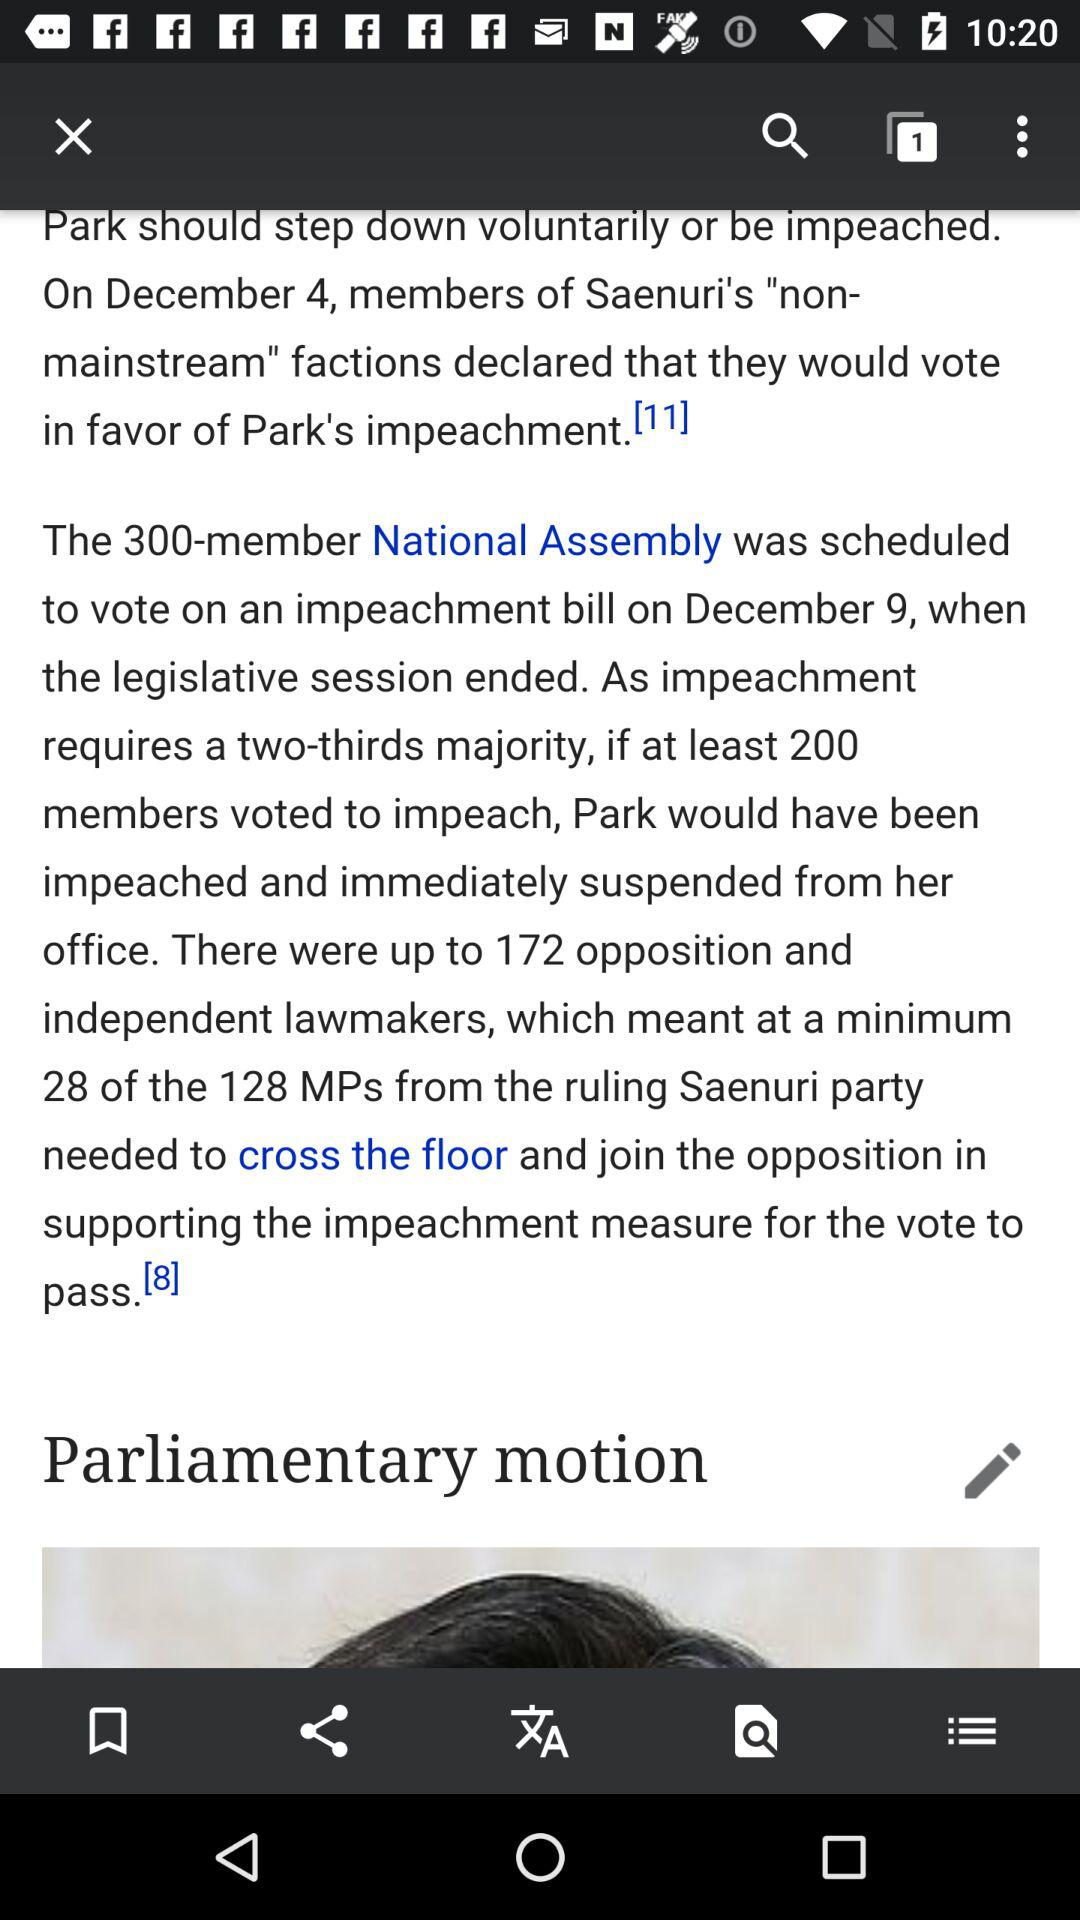How many more Saenuri party members would need to cross the floor and join the opposition to support the impeachment measure for the vote to pass?
Answer the question using a single word or phrase. 28 